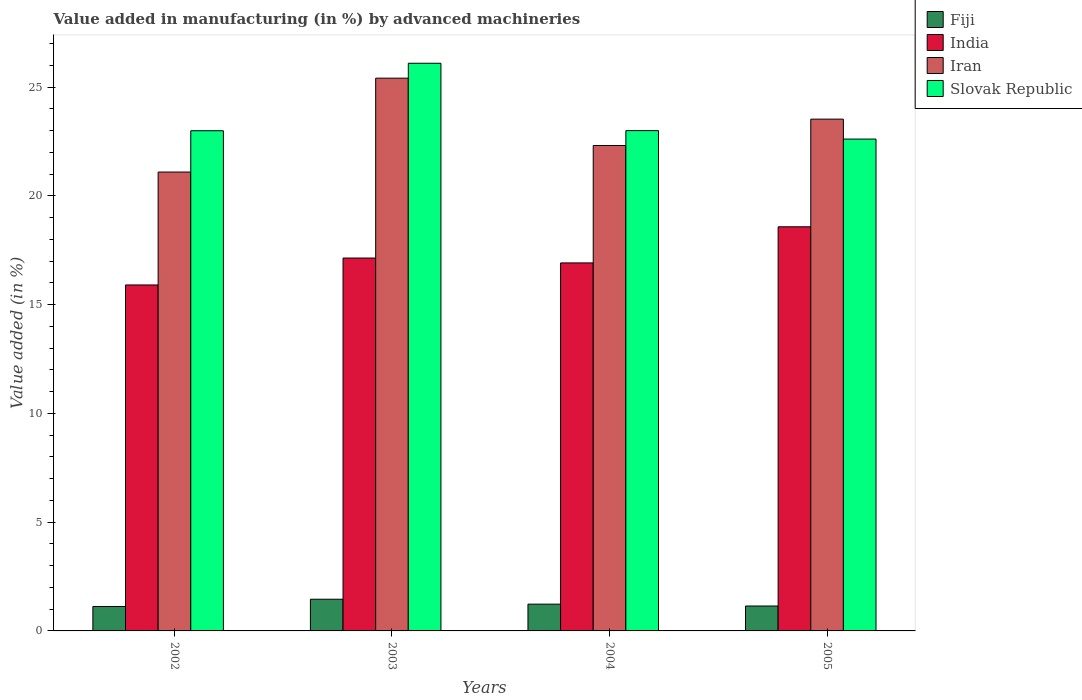How many groups of bars are there?
Ensure brevity in your answer.  4. Are the number of bars per tick equal to the number of legend labels?
Provide a succinct answer. Yes. How many bars are there on the 4th tick from the left?
Make the answer very short. 4. What is the label of the 3rd group of bars from the left?
Ensure brevity in your answer.  2004. What is the percentage of value added in manufacturing by advanced machineries in Fiji in 2003?
Keep it short and to the point. 1.46. Across all years, what is the maximum percentage of value added in manufacturing by advanced machineries in Fiji?
Ensure brevity in your answer.  1.46. Across all years, what is the minimum percentage of value added in manufacturing by advanced machineries in Fiji?
Provide a short and direct response. 1.12. In which year was the percentage of value added in manufacturing by advanced machineries in Slovak Republic minimum?
Provide a succinct answer. 2005. What is the total percentage of value added in manufacturing by advanced machineries in Fiji in the graph?
Keep it short and to the point. 4.96. What is the difference between the percentage of value added in manufacturing by advanced machineries in Iran in 2003 and that in 2004?
Offer a very short reply. 3.1. What is the difference between the percentage of value added in manufacturing by advanced machineries in Fiji in 2005 and the percentage of value added in manufacturing by advanced machineries in Slovak Republic in 2002?
Provide a short and direct response. -21.85. What is the average percentage of value added in manufacturing by advanced machineries in Fiji per year?
Offer a very short reply. 1.24. In the year 2003, what is the difference between the percentage of value added in manufacturing by advanced machineries in Fiji and percentage of value added in manufacturing by advanced machineries in Iran?
Ensure brevity in your answer.  -23.96. What is the ratio of the percentage of value added in manufacturing by advanced machineries in Fiji in 2003 to that in 2005?
Make the answer very short. 1.27. Is the percentage of value added in manufacturing by advanced machineries in India in 2002 less than that in 2004?
Ensure brevity in your answer.  Yes. Is the difference between the percentage of value added in manufacturing by advanced machineries in Fiji in 2003 and 2005 greater than the difference between the percentage of value added in manufacturing by advanced machineries in Iran in 2003 and 2005?
Offer a very short reply. No. What is the difference between the highest and the second highest percentage of value added in manufacturing by advanced machineries in Fiji?
Your answer should be very brief. 0.23. What is the difference between the highest and the lowest percentage of value added in manufacturing by advanced machineries in India?
Keep it short and to the point. 2.67. Is the sum of the percentage of value added in manufacturing by advanced machineries in India in 2002 and 2004 greater than the maximum percentage of value added in manufacturing by advanced machineries in Slovak Republic across all years?
Offer a terse response. Yes. What does the 1st bar from the left in 2003 represents?
Offer a terse response. Fiji. What does the 3rd bar from the right in 2005 represents?
Provide a short and direct response. India. Is it the case that in every year, the sum of the percentage of value added in manufacturing by advanced machineries in India and percentage of value added in manufacturing by advanced machineries in Slovak Republic is greater than the percentage of value added in manufacturing by advanced machineries in Iran?
Provide a succinct answer. Yes. How many bars are there?
Give a very brief answer. 16. Are all the bars in the graph horizontal?
Keep it short and to the point. No. Does the graph contain grids?
Ensure brevity in your answer.  No. How many legend labels are there?
Your answer should be compact. 4. How are the legend labels stacked?
Offer a terse response. Vertical. What is the title of the graph?
Offer a terse response. Value added in manufacturing (in %) by advanced machineries. What is the label or title of the Y-axis?
Ensure brevity in your answer.  Value added (in %). What is the Value added (in %) of Fiji in 2002?
Give a very brief answer. 1.12. What is the Value added (in %) of India in 2002?
Keep it short and to the point. 15.91. What is the Value added (in %) of Iran in 2002?
Your answer should be very brief. 21.1. What is the Value added (in %) in Slovak Republic in 2002?
Your response must be concise. 23. What is the Value added (in %) in Fiji in 2003?
Provide a succinct answer. 1.46. What is the Value added (in %) in India in 2003?
Offer a terse response. 17.14. What is the Value added (in %) in Iran in 2003?
Keep it short and to the point. 25.41. What is the Value added (in %) of Slovak Republic in 2003?
Give a very brief answer. 26.1. What is the Value added (in %) in Fiji in 2004?
Your response must be concise. 1.23. What is the Value added (in %) of India in 2004?
Provide a short and direct response. 16.92. What is the Value added (in %) of Iran in 2004?
Ensure brevity in your answer.  22.32. What is the Value added (in %) of Slovak Republic in 2004?
Offer a terse response. 23. What is the Value added (in %) of Fiji in 2005?
Offer a terse response. 1.15. What is the Value added (in %) in India in 2005?
Give a very brief answer. 18.58. What is the Value added (in %) in Iran in 2005?
Provide a succinct answer. 23.53. What is the Value added (in %) in Slovak Republic in 2005?
Offer a very short reply. 22.61. Across all years, what is the maximum Value added (in %) of Fiji?
Give a very brief answer. 1.46. Across all years, what is the maximum Value added (in %) of India?
Keep it short and to the point. 18.58. Across all years, what is the maximum Value added (in %) in Iran?
Keep it short and to the point. 25.41. Across all years, what is the maximum Value added (in %) of Slovak Republic?
Ensure brevity in your answer.  26.1. Across all years, what is the minimum Value added (in %) of Fiji?
Your response must be concise. 1.12. Across all years, what is the minimum Value added (in %) in India?
Your answer should be compact. 15.91. Across all years, what is the minimum Value added (in %) of Iran?
Make the answer very short. 21.1. Across all years, what is the minimum Value added (in %) of Slovak Republic?
Your answer should be compact. 22.61. What is the total Value added (in %) of Fiji in the graph?
Your answer should be very brief. 4.96. What is the total Value added (in %) in India in the graph?
Your response must be concise. 68.55. What is the total Value added (in %) of Iran in the graph?
Your answer should be compact. 92.36. What is the total Value added (in %) in Slovak Republic in the graph?
Make the answer very short. 94.71. What is the difference between the Value added (in %) of Fiji in 2002 and that in 2003?
Keep it short and to the point. -0.33. What is the difference between the Value added (in %) in India in 2002 and that in 2003?
Provide a succinct answer. -1.24. What is the difference between the Value added (in %) of Iran in 2002 and that in 2003?
Provide a short and direct response. -4.32. What is the difference between the Value added (in %) of Slovak Republic in 2002 and that in 2003?
Make the answer very short. -3.1. What is the difference between the Value added (in %) in Fiji in 2002 and that in 2004?
Your answer should be compact. -0.11. What is the difference between the Value added (in %) in India in 2002 and that in 2004?
Your answer should be very brief. -1.01. What is the difference between the Value added (in %) in Iran in 2002 and that in 2004?
Make the answer very short. -1.22. What is the difference between the Value added (in %) of Slovak Republic in 2002 and that in 2004?
Offer a terse response. -0.01. What is the difference between the Value added (in %) of Fiji in 2002 and that in 2005?
Make the answer very short. -0.02. What is the difference between the Value added (in %) of India in 2002 and that in 2005?
Keep it short and to the point. -2.67. What is the difference between the Value added (in %) of Iran in 2002 and that in 2005?
Offer a terse response. -2.43. What is the difference between the Value added (in %) in Slovak Republic in 2002 and that in 2005?
Your answer should be very brief. 0.38. What is the difference between the Value added (in %) of Fiji in 2003 and that in 2004?
Provide a succinct answer. 0.23. What is the difference between the Value added (in %) of India in 2003 and that in 2004?
Your response must be concise. 0.22. What is the difference between the Value added (in %) in Iran in 2003 and that in 2004?
Offer a terse response. 3.1. What is the difference between the Value added (in %) of Slovak Republic in 2003 and that in 2004?
Ensure brevity in your answer.  3.1. What is the difference between the Value added (in %) in Fiji in 2003 and that in 2005?
Offer a terse response. 0.31. What is the difference between the Value added (in %) of India in 2003 and that in 2005?
Provide a succinct answer. -1.44. What is the difference between the Value added (in %) in Iran in 2003 and that in 2005?
Offer a terse response. 1.88. What is the difference between the Value added (in %) of Slovak Republic in 2003 and that in 2005?
Offer a terse response. 3.49. What is the difference between the Value added (in %) of Fiji in 2004 and that in 2005?
Offer a terse response. 0.09. What is the difference between the Value added (in %) of India in 2004 and that in 2005?
Offer a terse response. -1.66. What is the difference between the Value added (in %) in Iran in 2004 and that in 2005?
Provide a succinct answer. -1.21. What is the difference between the Value added (in %) of Slovak Republic in 2004 and that in 2005?
Your response must be concise. 0.39. What is the difference between the Value added (in %) in Fiji in 2002 and the Value added (in %) in India in 2003?
Ensure brevity in your answer.  -16.02. What is the difference between the Value added (in %) in Fiji in 2002 and the Value added (in %) in Iran in 2003?
Provide a short and direct response. -24.29. What is the difference between the Value added (in %) in Fiji in 2002 and the Value added (in %) in Slovak Republic in 2003?
Offer a very short reply. -24.98. What is the difference between the Value added (in %) of India in 2002 and the Value added (in %) of Iran in 2003?
Provide a succinct answer. -9.51. What is the difference between the Value added (in %) in India in 2002 and the Value added (in %) in Slovak Republic in 2003?
Your answer should be compact. -10.19. What is the difference between the Value added (in %) in Iran in 2002 and the Value added (in %) in Slovak Republic in 2003?
Your answer should be very brief. -5. What is the difference between the Value added (in %) of Fiji in 2002 and the Value added (in %) of India in 2004?
Offer a terse response. -15.8. What is the difference between the Value added (in %) in Fiji in 2002 and the Value added (in %) in Iran in 2004?
Provide a short and direct response. -21.2. What is the difference between the Value added (in %) of Fiji in 2002 and the Value added (in %) of Slovak Republic in 2004?
Ensure brevity in your answer.  -21.88. What is the difference between the Value added (in %) of India in 2002 and the Value added (in %) of Iran in 2004?
Offer a terse response. -6.41. What is the difference between the Value added (in %) in India in 2002 and the Value added (in %) in Slovak Republic in 2004?
Your answer should be very brief. -7.1. What is the difference between the Value added (in %) of Iran in 2002 and the Value added (in %) of Slovak Republic in 2004?
Keep it short and to the point. -1.9. What is the difference between the Value added (in %) in Fiji in 2002 and the Value added (in %) in India in 2005?
Your answer should be very brief. -17.46. What is the difference between the Value added (in %) in Fiji in 2002 and the Value added (in %) in Iran in 2005?
Your answer should be compact. -22.41. What is the difference between the Value added (in %) of Fiji in 2002 and the Value added (in %) of Slovak Republic in 2005?
Your answer should be compact. -21.49. What is the difference between the Value added (in %) in India in 2002 and the Value added (in %) in Iran in 2005?
Give a very brief answer. -7.62. What is the difference between the Value added (in %) of India in 2002 and the Value added (in %) of Slovak Republic in 2005?
Your answer should be very brief. -6.71. What is the difference between the Value added (in %) of Iran in 2002 and the Value added (in %) of Slovak Republic in 2005?
Your answer should be very brief. -1.52. What is the difference between the Value added (in %) of Fiji in 2003 and the Value added (in %) of India in 2004?
Your answer should be compact. -15.46. What is the difference between the Value added (in %) in Fiji in 2003 and the Value added (in %) in Iran in 2004?
Provide a short and direct response. -20.86. What is the difference between the Value added (in %) of Fiji in 2003 and the Value added (in %) of Slovak Republic in 2004?
Provide a succinct answer. -21.55. What is the difference between the Value added (in %) in India in 2003 and the Value added (in %) in Iran in 2004?
Provide a short and direct response. -5.17. What is the difference between the Value added (in %) in India in 2003 and the Value added (in %) in Slovak Republic in 2004?
Provide a succinct answer. -5.86. What is the difference between the Value added (in %) of Iran in 2003 and the Value added (in %) of Slovak Republic in 2004?
Offer a terse response. 2.41. What is the difference between the Value added (in %) in Fiji in 2003 and the Value added (in %) in India in 2005?
Offer a very short reply. -17.12. What is the difference between the Value added (in %) of Fiji in 2003 and the Value added (in %) of Iran in 2005?
Make the answer very short. -22.07. What is the difference between the Value added (in %) in Fiji in 2003 and the Value added (in %) in Slovak Republic in 2005?
Give a very brief answer. -21.16. What is the difference between the Value added (in %) of India in 2003 and the Value added (in %) of Iran in 2005?
Ensure brevity in your answer.  -6.39. What is the difference between the Value added (in %) in India in 2003 and the Value added (in %) in Slovak Republic in 2005?
Offer a very short reply. -5.47. What is the difference between the Value added (in %) of Iran in 2003 and the Value added (in %) of Slovak Republic in 2005?
Provide a short and direct response. 2.8. What is the difference between the Value added (in %) in Fiji in 2004 and the Value added (in %) in India in 2005?
Keep it short and to the point. -17.35. What is the difference between the Value added (in %) in Fiji in 2004 and the Value added (in %) in Iran in 2005?
Keep it short and to the point. -22.3. What is the difference between the Value added (in %) of Fiji in 2004 and the Value added (in %) of Slovak Republic in 2005?
Offer a very short reply. -21.38. What is the difference between the Value added (in %) in India in 2004 and the Value added (in %) in Iran in 2005?
Offer a terse response. -6.61. What is the difference between the Value added (in %) of India in 2004 and the Value added (in %) of Slovak Republic in 2005?
Offer a very short reply. -5.69. What is the difference between the Value added (in %) of Iran in 2004 and the Value added (in %) of Slovak Republic in 2005?
Give a very brief answer. -0.3. What is the average Value added (in %) of Fiji per year?
Offer a very short reply. 1.24. What is the average Value added (in %) of India per year?
Offer a very short reply. 17.14. What is the average Value added (in %) of Iran per year?
Offer a very short reply. 23.09. What is the average Value added (in %) in Slovak Republic per year?
Give a very brief answer. 23.68. In the year 2002, what is the difference between the Value added (in %) of Fiji and Value added (in %) of India?
Your answer should be very brief. -14.78. In the year 2002, what is the difference between the Value added (in %) of Fiji and Value added (in %) of Iran?
Give a very brief answer. -19.97. In the year 2002, what is the difference between the Value added (in %) of Fiji and Value added (in %) of Slovak Republic?
Keep it short and to the point. -21.87. In the year 2002, what is the difference between the Value added (in %) of India and Value added (in %) of Iran?
Your answer should be compact. -5.19. In the year 2002, what is the difference between the Value added (in %) of India and Value added (in %) of Slovak Republic?
Keep it short and to the point. -7.09. In the year 2002, what is the difference between the Value added (in %) of Iran and Value added (in %) of Slovak Republic?
Make the answer very short. -1.9. In the year 2003, what is the difference between the Value added (in %) of Fiji and Value added (in %) of India?
Provide a short and direct response. -15.69. In the year 2003, what is the difference between the Value added (in %) of Fiji and Value added (in %) of Iran?
Provide a succinct answer. -23.96. In the year 2003, what is the difference between the Value added (in %) of Fiji and Value added (in %) of Slovak Republic?
Offer a terse response. -24.64. In the year 2003, what is the difference between the Value added (in %) of India and Value added (in %) of Iran?
Your answer should be very brief. -8.27. In the year 2003, what is the difference between the Value added (in %) in India and Value added (in %) in Slovak Republic?
Make the answer very short. -8.96. In the year 2003, what is the difference between the Value added (in %) of Iran and Value added (in %) of Slovak Republic?
Offer a very short reply. -0.69. In the year 2004, what is the difference between the Value added (in %) in Fiji and Value added (in %) in India?
Your answer should be compact. -15.69. In the year 2004, what is the difference between the Value added (in %) of Fiji and Value added (in %) of Iran?
Your answer should be very brief. -21.09. In the year 2004, what is the difference between the Value added (in %) of Fiji and Value added (in %) of Slovak Republic?
Offer a very short reply. -21.77. In the year 2004, what is the difference between the Value added (in %) of India and Value added (in %) of Iran?
Your answer should be compact. -5.4. In the year 2004, what is the difference between the Value added (in %) in India and Value added (in %) in Slovak Republic?
Offer a very short reply. -6.08. In the year 2004, what is the difference between the Value added (in %) in Iran and Value added (in %) in Slovak Republic?
Offer a terse response. -0.68. In the year 2005, what is the difference between the Value added (in %) of Fiji and Value added (in %) of India?
Your response must be concise. -17.44. In the year 2005, what is the difference between the Value added (in %) in Fiji and Value added (in %) in Iran?
Keep it short and to the point. -22.38. In the year 2005, what is the difference between the Value added (in %) of Fiji and Value added (in %) of Slovak Republic?
Ensure brevity in your answer.  -21.47. In the year 2005, what is the difference between the Value added (in %) in India and Value added (in %) in Iran?
Provide a short and direct response. -4.95. In the year 2005, what is the difference between the Value added (in %) of India and Value added (in %) of Slovak Republic?
Your answer should be compact. -4.03. In the year 2005, what is the difference between the Value added (in %) of Iran and Value added (in %) of Slovak Republic?
Your answer should be very brief. 0.92. What is the ratio of the Value added (in %) of Fiji in 2002 to that in 2003?
Make the answer very short. 0.77. What is the ratio of the Value added (in %) of India in 2002 to that in 2003?
Give a very brief answer. 0.93. What is the ratio of the Value added (in %) of Iran in 2002 to that in 2003?
Keep it short and to the point. 0.83. What is the ratio of the Value added (in %) in Slovak Republic in 2002 to that in 2003?
Give a very brief answer. 0.88. What is the ratio of the Value added (in %) in Fiji in 2002 to that in 2004?
Offer a very short reply. 0.91. What is the ratio of the Value added (in %) in India in 2002 to that in 2004?
Your answer should be compact. 0.94. What is the ratio of the Value added (in %) of Iran in 2002 to that in 2004?
Your answer should be compact. 0.95. What is the ratio of the Value added (in %) in Fiji in 2002 to that in 2005?
Offer a terse response. 0.98. What is the ratio of the Value added (in %) in India in 2002 to that in 2005?
Ensure brevity in your answer.  0.86. What is the ratio of the Value added (in %) of Iran in 2002 to that in 2005?
Give a very brief answer. 0.9. What is the ratio of the Value added (in %) of Slovak Republic in 2002 to that in 2005?
Offer a very short reply. 1.02. What is the ratio of the Value added (in %) of Fiji in 2003 to that in 2004?
Provide a short and direct response. 1.18. What is the ratio of the Value added (in %) in India in 2003 to that in 2004?
Provide a short and direct response. 1.01. What is the ratio of the Value added (in %) in Iran in 2003 to that in 2004?
Provide a short and direct response. 1.14. What is the ratio of the Value added (in %) in Slovak Republic in 2003 to that in 2004?
Your response must be concise. 1.13. What is the ratio of the Value added (in %) of Fiji in 2003 to that in 2005?
Offer a terse response. 1.27. What is the ratio of the Value added (in %) in India in 2003 to that in 2005?
Give a very brief answer. 0.92. What is the ratio of the Value added (in %) in Iran in 2003 to that in 2005?
Provide a short and direct response. 1.08. What is the ratio of the Value added (in %) in Slovak Republic in 2003 to that in 2005?
Your answer should be compact. 1.15. What is the ratio of the Value added (in %) of Fiji in 2004 to that in 2005?
Make the answer very short. 1.07. What is the ratio of the Value added (in %) of India in 2004 to that in 2005?
Make the answer very short. 0.91. What is the ratio of the Value added (in %) of Iran in 2004 to that in 2005?
Offer a very short reply. 0.95. What is the ratio of the Value added (in %) in Slovak Republic in 2004 to that in 2005?
Ensure brevity in your answer.  1.02. What is the difference between the highest and the second highest Value added (in %) in Fiji?
Make the answer very short. 0.23. What is the difference between the highest and the second highest Value added (in %) in India?
Keep it short and to the point. 1.44. What is the difference between the highest and the second highest Value added (in %) in Iran?
Your response must be concise. 1.88. What is the difference between the highest and the second highest Value added (in %) of Slovak Republic?
Keep it short and to the point. 3.1. What is the difference between the highest and the lowest Value added (in %) of Fiji?
Offer a terse response. 0.33. What is the difference between the highest and the lowest Value added (in %) in India?
Make the answer very short. 2.67. What is the difference between the highest and the lowest Value added (in %) in Iran?
Make the answer very short. 4.32. What is the difference between the highest and the lowest Value added (in %) in Slovak Republic?
Give a very brief answer. 3.49. 